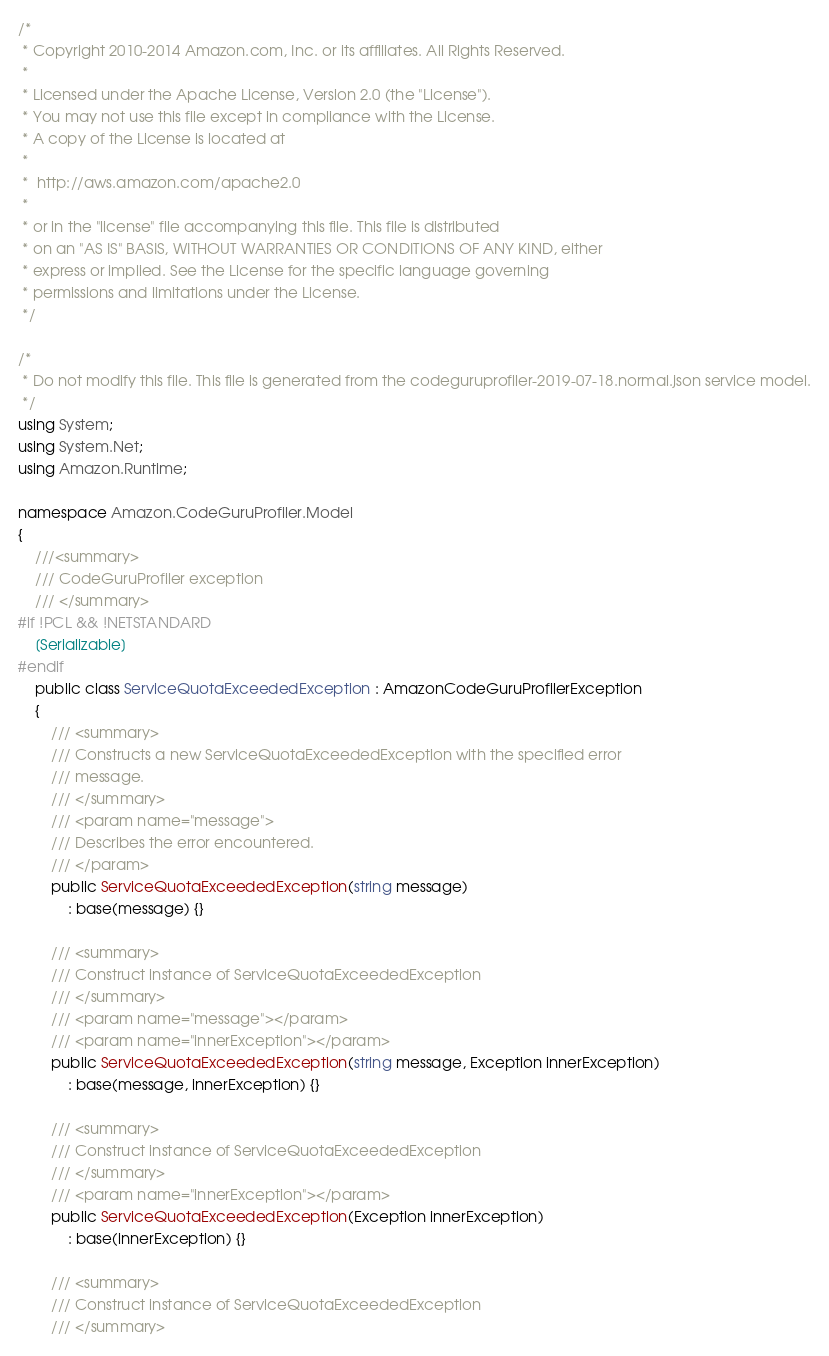<code> <loc_0><loc_0><loc_500><loc_500><_C#_>/*
 * Copyright 2010-2014 Amazon.com, Inc. or its affiliates. All Rights Reserved.
 * 
 * Licensed under the Apache License, Version 2.0 (the "License").
 * You may not use this file except in compliance with the License.
 * A copy of the License is located at
 * 
 *  http://aws.amazon.com/apache2.0
 * 
 * or in the "license" file accompanying this file. This file is distributed
 * on an "AS IS" BASIS, WITHOUT WARRANTIES OR CONDITIONS OF ANY KIND, either
 * express or implied. See the License for the specific language governing
 * permissions and limitations under the License.
 */

/*
 * Do not modify this file. This file is generated from the codeguruprofiler-2019-07-18.normal.json service model.
 */
using System;
using System.Net;
using Amazon.Runtime;

namespace Amazon.CodeGuruProfiler.Model
{
    ///<summary>
    /// CodeGuruProfiler exception
    /// </summary>
#if !PCL && !NETSTANDARD
    [Serializable]
#endif
    public class ServiceQuotaExceededException : AmazonCodeGuruProfilerException 
    {
        /// <summary>
        /// Constructs a new ServiceQuotaExceededException with the specified error
        /// message.
        /// </summary>
        /// <param name="message">
        /// Describes the error encountered.
        /// </param>
        public ServiceQuotaExceededException(string message) 
            : base(message) {}
          
        /// <summary>
        /// Construct instance of ServiceQuotaExceededException
        /// </summary>
        /// <param name="message"></param>
        /// <param name="innerException"></param>
        public ServiceQuotaExceededException(string message, Exception innerException) 
            : base(message, innerException) {}
            
        /// <summary>
        /// Construct instance of ServiceQuotaExceededException
        /// </summary>
        /// <param name="innerException"></param>
        public ServiceQuotaExceededException(Exception innerException) 
            : base(innerException) {}
            
        /// <summary>
        /// Construct instance of ServiceQuotaExceededException
        /// </summary></code> 